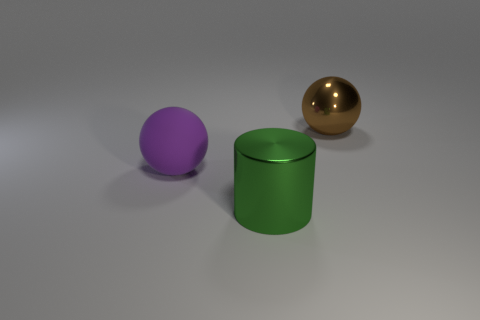Add 2 large brown metallic balls. How many objects exist? 5 Subtract all cylinders. How many objects are left? 2 Add 1 big green objects. How many big green objects are left? 2 Add 3 green metallic cylinders. How many green metallic cylinders exist? 4 Subtract 0 purple blocks. How many objects are left? 3 Subtract all green metal cylinders. Subtract all tiny cyan matte balls. How many objects are left? 2 